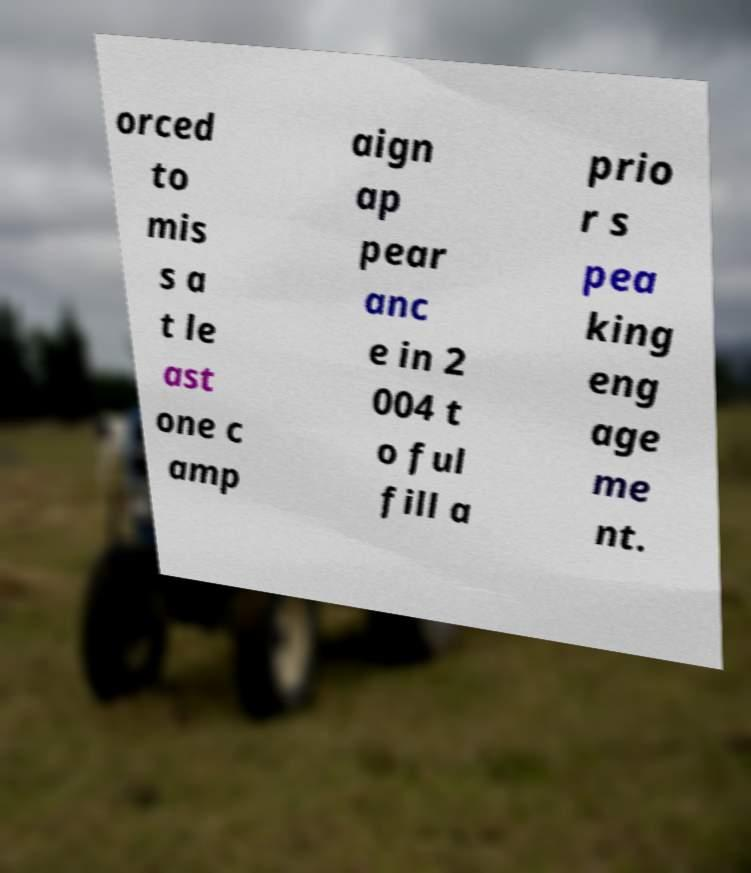Can you accurately transcribe the text from the provided image for me? orced to mis s a t le ast one c amp aign ap pear anc e in 2 004 t o ful fill a prio r s pea king eng age me nt. 